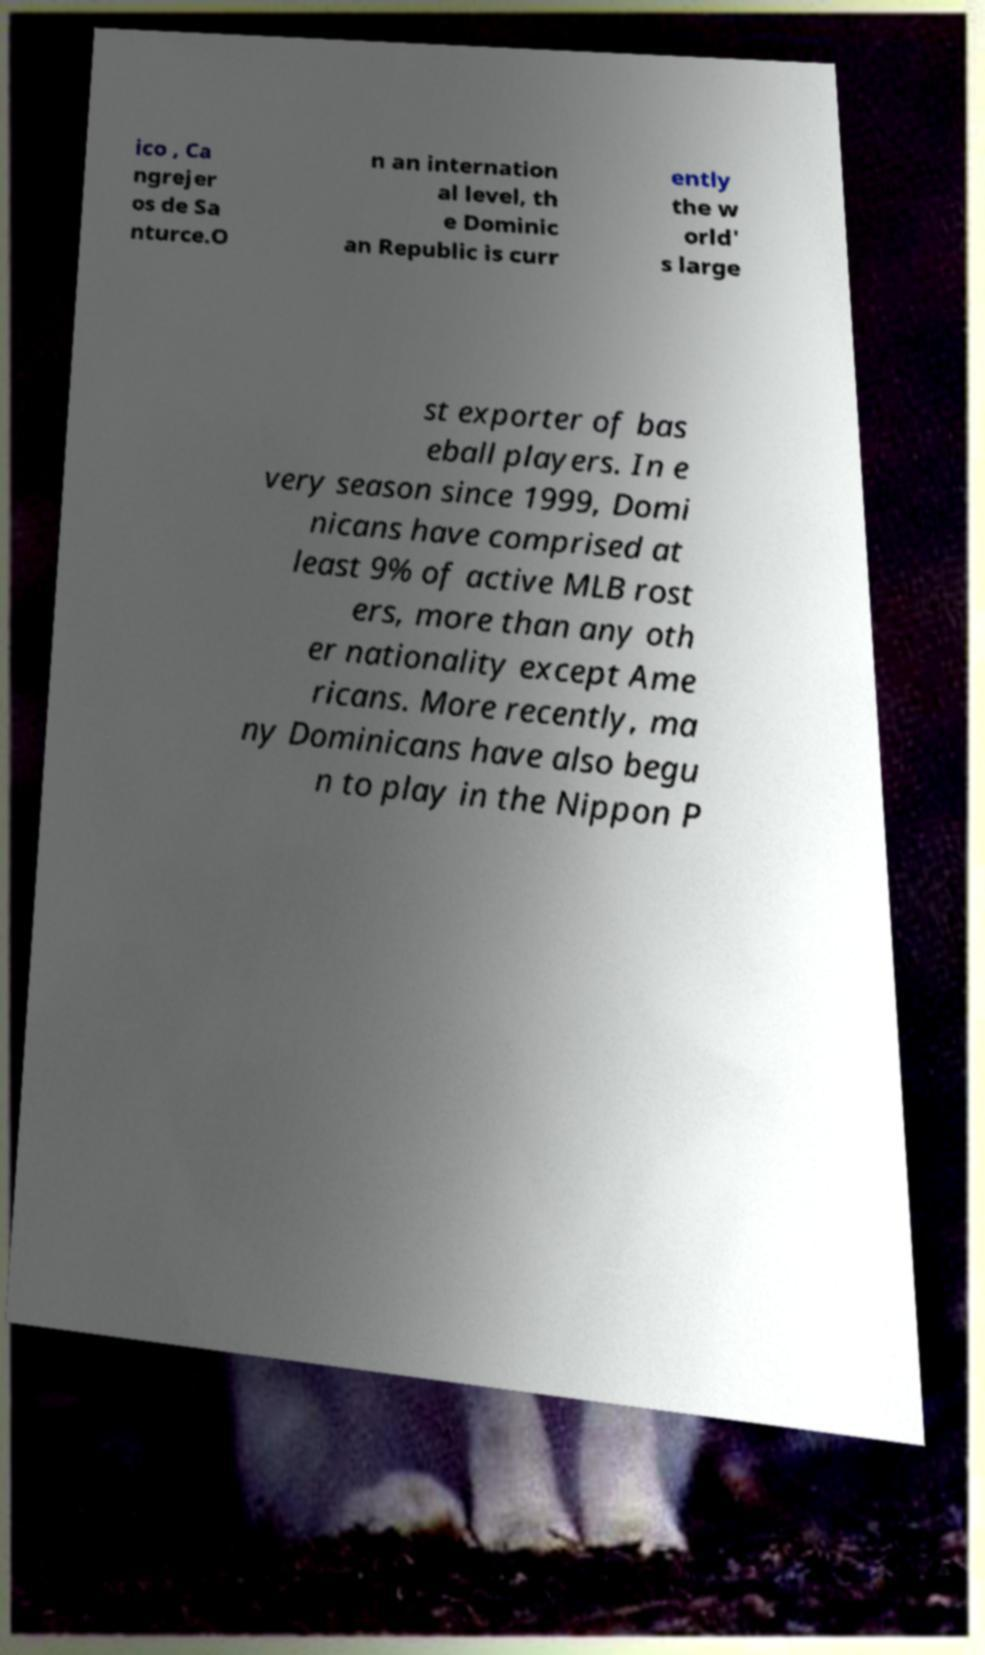Can you accurately transcribe the text from the provided image for me? ico , Ca ngrejer os de Sa nturce.O n an internation al level, th e Dominic an Republic is curr ently the w orld' s large st exporter of bas eball players. In e very season since 1999, Domi nicans have comprised at least 9% of active MLB rost ers, more than any oth er nationality except Ame ricans. More recently, ma ny Dominicans have also begu n to play in the Nippon P 